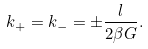<formula> <loc_0><loc_0><loc_500><loc_500>k _ { + } = k _ { - } = \pm \frac { l } { 2 \beta G } .</formula> 